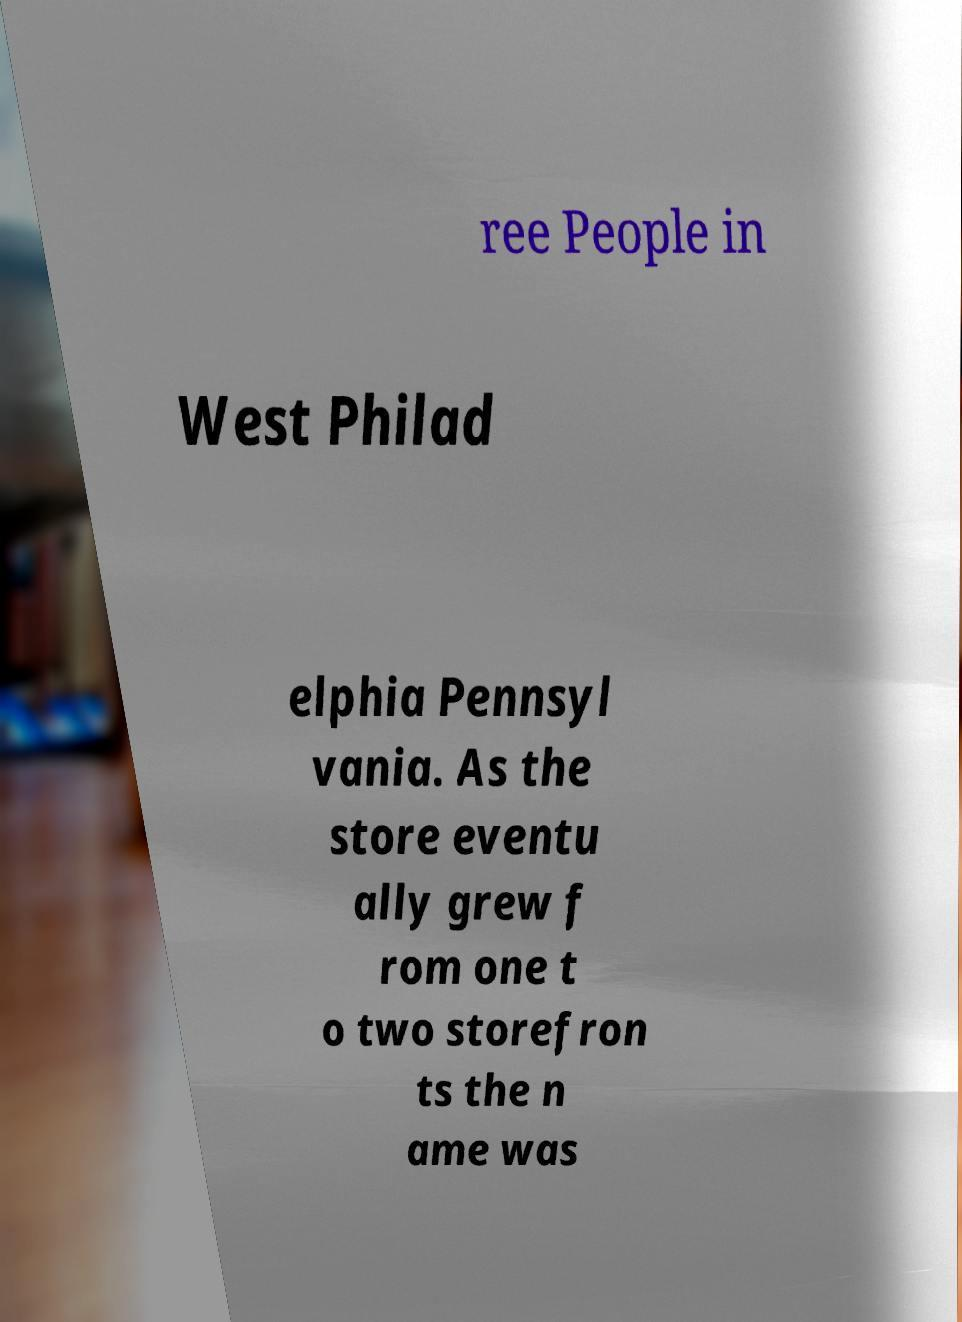For documentation purposes, I need the text within this image transcribed. Could you provide that? ree People in West Philad elphia Pennsyl vania. As the store eventu ally grew f rom one t o two storefron ts the n ame was 